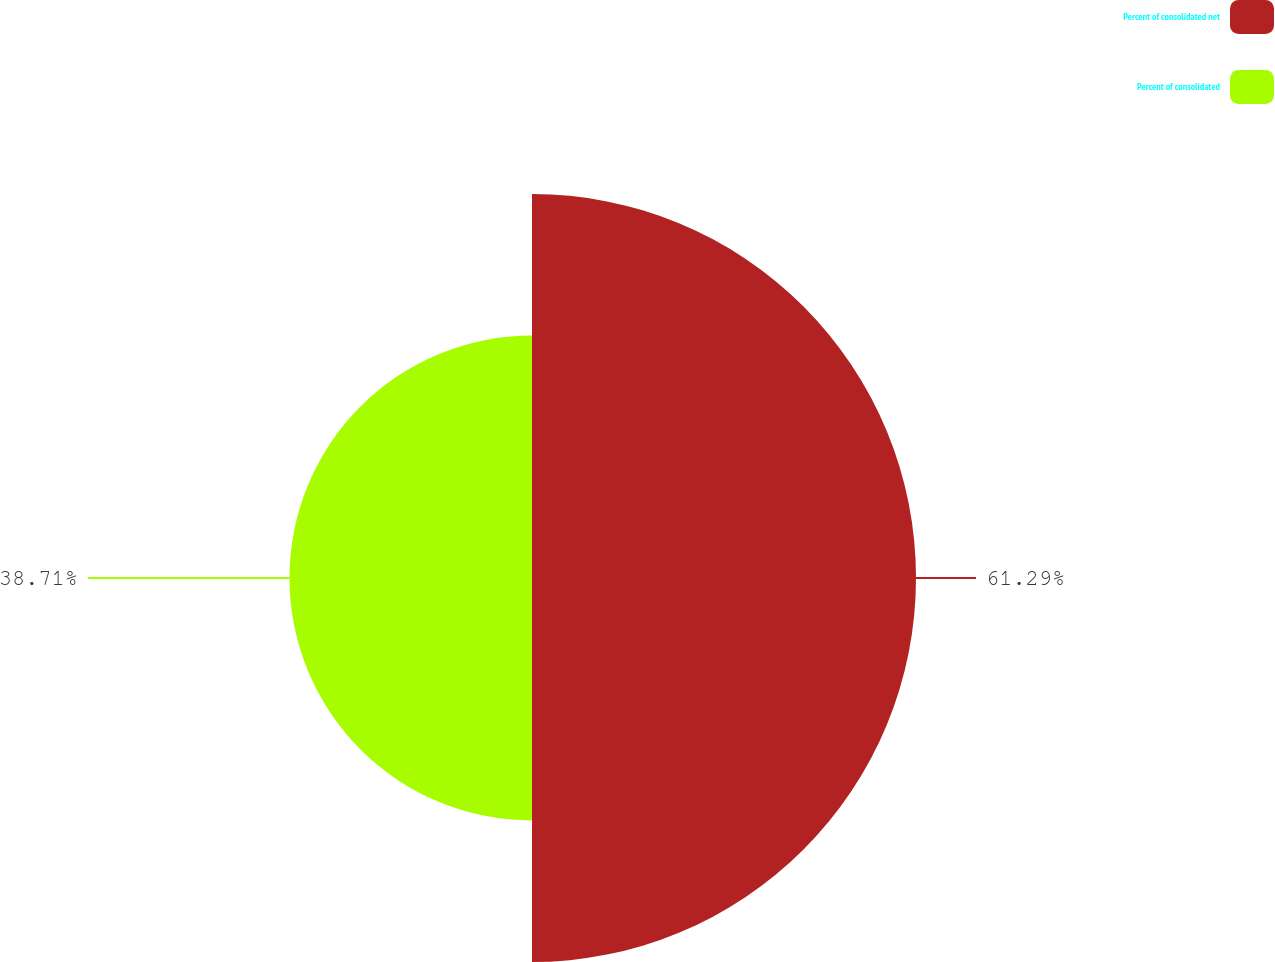Convert chart. <chart><loc_0><loc_0><loc_500><loc_500><pie_chart><fcel>Percent of consolidated net<fcel>Percent of consolidated<nl><fcel>61.29%<fcel>38.71%<nl></chart> 